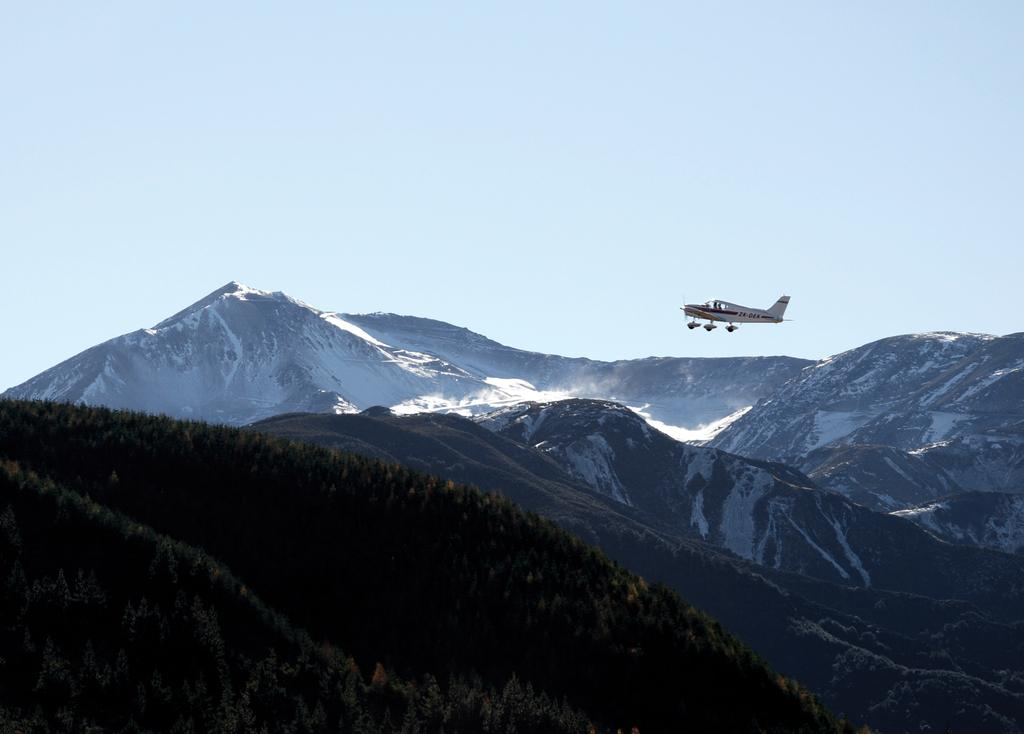What type of natural landscape is visible in the image? There are hills in the image. What type of vegetation is present in the image? There are trees in the image. What man-made object can be seen in the image? There is a plane in the image. What is visible at the top of the image? The sky is visible at the top of the image. How does the door open in the image? There is no door present in the image. What type of motion can be seen in the image? There is no motion visible in the image; the objects are stationary. 